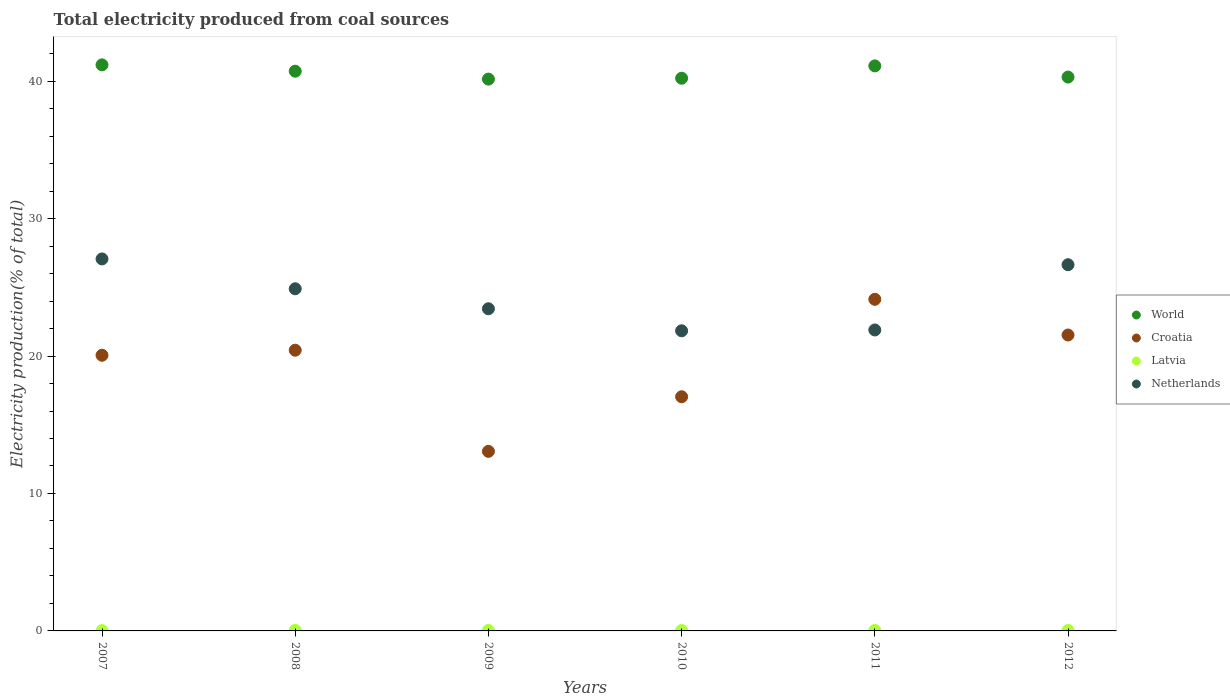How many different coloured dotlines are there?
Your answer should be compact. 4. Is the number of dotlines equal to the number of legend labels?
Make the answer very short. Yes. What is the total electricity produced in Latvia in 2010?
Your response must be concise. 0.03. Across all years, what is the maximum total electricity produced in Latvia?
Offer a very short reply. 0.04. Across all years, what is the minimum total electricity produced in World?
Make the answer very short. 40.15. What is the total total electricity produced in Croatia in the graph?
Give a very brief answer. 116.24. What is the difference between the total electricity produced in Netherlands in 2011 and that in 2012?
Your response must be concise. -4.75. What is the difference between the total electricity produced in Latvia in 2008 and the total electricity produced in World in 2007?
Offer a terse response. -41.15. What is the average total electricity produced in Netherlands per year?
Your answer should be compact. 24.3. In the year 2008, what is the difference between the total electricity produced in Netherlands and total electricity produced in World?
Your response must be concise. -15.83. What is the ratio of the total electricity produced in Netherlands in 2009 to that in 2010?
Keep it short and to the point. 1.07. What is the difference between the highest and the second highest total electricity produced in World?
Offer a terse response. 0.07. What is the difference between the highest and the lowest total electricity produced in Latvia?
Offer a very short reply. 0.02. In how many years, is the total electricity produced in Latvia greater than the average total electricity produced in Latvia taken over all years?
Keep it short and to the point. 4. Is the sum of the total electricity produced in Netherlands in 2010 and 2011 greater than the maximum total electricity produced in Latvia across all years?
Offer a very short reply. Yes. Is it the case that in every year, the sum of the total electricity produced in Latvia and total electricity produced in World  is greater than the total electricity produced in Netherlands?
Your answer should be compact. Yes. Is the total electricity produced in Netherlands strictly greater than the total electricity produced in Croatia over the years?
Provide a succinct answer. No. Is the total electricity produced in Netherlands strictly less than the total electricity produced in Latvia over the years?
Your answer should be compact. No. How many years are there in the graph?
Give a very brief answer. 6. What is the difference between two consecutive major ticks on the Y-axis?
Provide a succinct answer. 10. Does the graph contain grids?
Your answer should be very brief. No. Where does the legend appear in the graph?
Make the answer very short. Center right. How many legend labels are there?
Give a very brief answer. 4. How are the legend labels stacked?
Offer a very short reply. Vertical. What is the title of the graph?
Your answer should be very brief. Total electricity produced from coal sources. Does "Costa Rica" appear as one of the legend labels in the graph?
Keep it short and to the point. No. What is the label or title of the Y-axis?
Your answer should be compact. Electricity production(% of total). What is the Electricity production(% of total) of World in 2007?
Offer a very short reply. 41.18. What is the Electricity production(% of total) in Croatia in 2007?
Keep it short and to the point. 20.06. What is the Electricity production(% of total) of Latvia in 2007?
Your response must be concise. 0.02. What is the Electricity production(% of total) in Netherlands in 2007?
Provide a succinct answer. 27.06. What is the Electricity production(% of total) in World in 2008?
Your response must be concise. 40.72. What is the Electricity production(% of total) of Croatia in 2008?
Keep it short and to the point. 20.42. What is the Electricity production(% of total) of Latvia in 2008?
Give a very brief answer. 0.04. What is the Electricity production(% of total) of Netherlands in 2008?
Provide a short and direct response. 24.89. What is the Electricity production(% of total) of World in 2009?
Your answer should be compact. 40.15. What is the Electricity production(% of total) of Croatia in 2009?
Your answer should be very brief. 13.06. What is the Electricity production(% of total) in Latvia in 2009?
Ensure brevity in your answer.  0.04. What is the Electricity production(% of total) in Netherlands in 2009?
Your answer should be compact. 23.44. What is the Electricity production(% of total) of World in 2010?
Your answer should be compact. 40.21. What is the Electricity production(% of total) in Croatia in 2010?
Your response must be concise. 17.04. What is the Electricity production(% of total) of Latvia in 2010?
Your answer should be very brief. 0.03. What is the Electricity production(% of total) in Netherlands in 2010?
Keep it short and to the point. 21.84. What is the Electricity production(% of total) of World in 2011?
Give a very brief answer. 41.11. What is the Electricity production(% of total) of Croatia in 2011?
Offer a very short reply. 24.13. What is the Electricity production(% of total) in Latvia in 2011?
Your answer should be very brief. 0.03. What is the Electricity production(% of total) of Netherlands in 2011?
Make the answer very short. 21.9. What is the Electricity production(% of total) of World in 2012?
Offer a terse response. 40.3. What is the Electricity production(% of total) of Croatia in 2012?
Ensure brevity in your answer.  21.53. What is the Electricity production(% of total) of Latvia in 2012?
Your response must be concise. 0.03. What is the Electricity production(% of total) of Netherlands in 2012?
Give a very brief answer. 26.64. Across all years, what is the maximum Electricity production(% of total) of World?
Your answer should be compact. 41.18. Across all years, what is the maximum Electricity production(% of total) in Croatia?
Keep it short and to the point. 24.13. Across all years, what is the maximum Electricity production(% of total) of Latvia?
Offer a terse response. 0.04. Across all years, what is the maximum Electricity production(% of total) in Netherlands?
Provide a short and direct response. 27.06. Across all years, what is the minimum Electricity production(% of total) in World?
Your answer should be very brief. 40.15. Across all years, what is the minimum Electricity production(% of total) of Croatia?
Your answer should be compact. 13.06. Across all years, what is the minimum Electricity production(% of total) in Latvia?
Make the answer very short. 0.02. Across all years, what is the minimum Electricity production(% of total) in Netherlands?
Offer a very short reply. 21.84. What is the total Electricity production(% of total) of World in the graph?
Provide a short and direct response. 243.68. What is the total Electricity production(% of total) of Croatia in the graph?
Make the answer very short. 116.24. What is the total Electricity production(% of total) in Latvia in the graph?
Provide a short and direct response. 0.19. What is the total Electricity production(% of total) in Netherlands in the graph?
Your answer should be very brief. 145.78. What is the difference between the Electricity production(% of total) in World in 2007 and that in 2008?
Make the answer very short. 0.46. What is the difference between the Electricity production(% of total) in Croatia in 2007 and that in 2008?
Offer a terse response. -0.37. What is the difference between the Electricity production(% of total) of Latvia in 2007 and that in 2008?
Make the answer very short. -0.02. What is the difference between the Electricity production(% of total) of Netherlands in 2007 and that in 2008?
Your response must be concise. 2.17. What is the difference between the Electricity production(% of total) in World in 2007 and that in 2009?
Your answer should be very brief. 1.04. What is the difference between the Electricity production(% of total) in Croatia in 2007 and that in 2009?
Your response must be concise. 6.99. What is the difference between the Electricity production(% of total) in Latvia in 2007 and that in 2009?
Keep it short and to the point. -0.01. What is the difference between the Electricity production(% of total) of Netherlands in 2007 and that in 2009?
Provide a succinct answer. 3.62. What is the difference between the Electricity production(% of total) in World in 2007 and that in 2010?
Your answer should be very brief. 0.97. What is the difference between the Electricity production(% of total) of Croatia in 2007 and that in 2010?
Your answer should be compact. 3.02. What is the difference between the Electricity production(% of total) in Latvia in 2007 and that in 2010?
Your response must be concise. -0.01. What is the difference between the Electricity production(% of total) of Netherlands in 2007 and that in 2010?
Your answer should be compact. 5.23. What is the difference between the Electricity production(% of total) in World in 2007 and that in 2011?
Make the answer very short. 0.07. What is the difference between the Electricity production(% of total) of Croatia in 2007 and that in 2011?
Ensure brevity in your answer.  -4.07. What is the difference between the Electricity production(% of total) of Latvia in 2007 and that in 2011?
Provide a succinct answer. -0.01. What is the difference between the Electricity production(% of total) in Netherlands in 2007 and that in 2011?
Provide a short and direct response. 5.17. What is the difference between the Electricity production(% of total) of World in 2007 and that in 2012?
Offer a terse response. 0.89. What is the difference between the Electricity production(% of total) of Croatia in 2007 and that in 2012?
Keep it short and to the point. -1.47. What is the difference between the Electricity production(% of total) in Latvia in 2007 and that in 2012?
Offer a terse response. -0.01. What is the difference between the Electricity production(% of total) of Netherlands in 2007 and that in 2012?
Ensure brevity in your answer.  0.42. What is the difference between the Electricity production(% of total) of World in 2008 and that in 2009?
Your response must be concise. 0.58. What is the difference between the Electricity production(% of total) of Croatia in 2008 and that in 2009?
Make the answer very short. 7.36. What is the difference between the Electricity production(% of total) in Latvia in 2008 and that in 2009?
Offer a terse response. 0. What is the difference between the Electricity production(% of total) of Netherlands in 2008 and that in 2009?
Your response must be concise. 1.45. What is the difference between the Electricity production(% of total) in World in 2008 and that in 2010?
Ensure brevity in your answer.  0.51. What is the difference between the Electricity production(% of total) in Croatia in 2008 and that in 2010?
Keep it short and to the point. 3.39. What is the difference between the Electricity production(% of total) in Latvia in 2008 and that in 2010?
Provide a succinct answer. 0.01. What is the difference between the Electricity production(% of total) in Netherlands in 2008 and that in 2010?
Keep it short and to the point. 3.06. What is the difference between the Electricity production(% of total) in World in 2008 and that in 2011?
Provide a succinct answer. -0.39. What is the difference between the Electricity production(% of total) in Croatia in 2008 and that in 2011?
Your answer should be compact. -3.7. What is the difference between the Electricity production(% of total) of Latvia in 2008 and that in 2011?
Your answer should be very brief. 0.01. What is the difference between the Electricity production(% of total) in Netherlands in 2008 and that in 2011?
Give a very brief answer. 3. What is the difference between the Electricity production(% of total) in World in 2008 and that in 2012?
Your answer should be very brief. 0.43. What is the difference between the Electricity production(% of total) in Croatia in 2008 and that in 2012?
Offer a terse response. -1.11. What is the difference between the Electricity production(% of total) in Latvia in 2008 and that in 2012?
Ensure brevity in your answer.  0.01. What is the difference between the Electricity production(% of total) of Netherlands in 2008 and that in 2012?
Your answer should be compact. -1.75. What is the difference between the Electricity production(% of total) in World in 2009 and that in 2010?
Ensure brevity in your answer.  -0.06. What is the difference between the Electricity production(% of total) in Croatia in 2009 and that in 2010?
Ensure brevity in your answer.  -3.97. What is the difference between the Electricity production(% of total) in Latvia in 2009 and that in 2010?
Your answer should be compact. 0.01. What is the difference between the Electricity production(% of total) in Netherlands in 2009 and that in 2010?
Ensure brevity in your answer.  1.6. What is the difference between the Electricity production(% of total) of World in 2009 and that in 2011?
Offer a very short reply. -0.96. What is the difference between the Electricity production(% of total) in Croatia in 2009 and that in 2011?
Your answer should be very brief. -11.06. What is the difference between the Electricity production(% of total) in Latvia in 2009 and that in 2011?
Your answer should be very brief. 0. What is the difference between the Electricity production(% of total) of Netherlands in 2009 and that in 2011?
Your answer should be very brief. 1.54. What is the difference between the Electricity production(% of total) of World in 2009 and that in 2012?
Keep it short and to the point. -0.15. What is the difference between the Electricity production(% of total) of Croatia in 2009 and that in 2012?
Provide a short and direct response. -8.47. What is the difference between the Electricity production(% of total) in Latvia in 2009 and that in 2012?
Give a very brief answer. 0. What is the difference between the Electricity production(% of total) in Netherlands in 2009 and that in 2012?
Provide a short and direct response. -3.2. What is the difference between the Electricity production(% of total) in World in 2010 and that in 2011?
Your response must be concise. -0.9. What is the difference between the Electricity production(% of total) of Croatia in 2010 and that in 2011?
Your answer should be very brief. -7.09. What is the difference between the Electricity production(% of total) in Latvia in 2010 and that in 2011?
Ensure brevity in your answer.  -0. What is the difference between the Electricity production(% of total) of Netherlands in 2010 and that in 2011?
Your answer should be compact. -0.06. What is the difference between the Electricity production(% of total) in World in 2010 and that in 2012?
Keep it short and to the point. -0.09. What is the difference between the Electricity production(% of total) in Croatia in 2010 and that in 2012?
Keep it short and to the point. -4.49. What is the difference between the Electricity production(% of total) of Latvia in 2010 and that in 2012?
Provide a short and direct response. -0. What is the difference between the Electricity production(% of total) of Netherlands in 2010 and that in 2012?
Offer a terse response. -4.81. What is the difference between the Electricity production(% of total) of World in 2011 and that in 2012?
Provide a short and direct response. 0.81. What is the difference between the Electricity production(% of total) in Croatia in 2011 and that in 2012?
Your response must be concise. 2.6. What is the difference between the Electricity production(% of total) in Netherlands in 2011 and that in 2012?
Provide a short and direct response. -4.75. What is the difference between the Electricity production(% of total) in World in 2007 and the Electricity production(% of total) in Croatia in 2008?
Provide a succinct answer. 20.76. What is the difference between the Electricity production(% of total) of World in 2007 and the Electricity production(% of total) of Latvia in 2008?
Give a very brief answer. 41.15. What is the difference between the Electricity production(% of total) in World in 2007 and the Electricity production(% of total) in Netherlands in 2008?
Your answer should be compact. 16.29. What is the difference between the Electricity production(% of total) of Croatia in 2007 and the Electricity production(% of total) of Latvia in 2008?
Make the answer very short. 20.02. What is the difference between the Electricity production(% of total) in Croatia in 2007 and the Electricity production(% of total) in Netherlands in 2008?
Ensure brevity in your answer.  -4.84. What is the difference between the Electricity production(% of total) in Latvia in 2007 and the Electricity production(% of total) in Netherlands in 2008?
Give a very brief answer. -24.87. What is the difference between the Electricity production(% of total) in World in 2007 and the Electricity production(% of total) in Croatia in 2009?
Your answer should be very brief. 28.12. What is the difference between the Electricity production(% of total) of World in 2007 and the Electricity production(% of total) of Latvia in 2009?
Make the answer very short. 41.15. What is the difference between the Electricity production(% of total) in World in 2007 and the Electricity production(% of total) in Netherlands in 2009?
Provide a succinct answer. 17.74. What is the difference between the Electricity production(% of total) in Croatia in 2007 and the Electricity production(% of total) in Latvia in 2009?
Ensure brevity in your answer.  20.02. What is the difference between the Electricity production(% of total) of Croatia in 2007 and the Electricity production(% of total) of Netherlands in 2009?
Your response must be concise. -3.38. What is the difference between the Electricity production(% of total) in Latvia in 2007 and the Electricity production(% of total) in Netherlands in 2009?
Give a very brief answer. -23.42. What is the difference between the Electricity production(% of total) of World in 2007 and the Electricity production(% of total) of Croatia in 2010?
Offer a very short reply. 24.15. What is the difference between the Electricity production(% of total) of World in 2007 and the Electricity production(% of total) of Latvia in 2010?
Make the answer very short. 41.15. What is the difference between the Electricity production(% of total) of World in 2007 and the Electricity production(% of total) of Netherlands in 2010?
Your response must be concise. 19.35. What is the difference between the Electricity production(% of total) in Croatia in 2007 and the Electricity production(% of total) in Latvia in 2010?
Ensure brevity in your answer.  20.03. What is the difference between the Electricity production(% of total) of Croatia in 2007 and the Electricity production(% of total) of Netherlands in 2010?
Make the answer very short. -1.78. What is the difference between the Electricity production(% of total) of Latvia in 2007 and the Electricity production(% of total) of Netherlands in 2010?
Offer a terse response. -21.82. What is the difference between the Electricity production(% of total) in World in 2007 and the Electricity production(% of total) in Croatia in 2011?
Your answer should be compact. 17.06. What is the difference between the Electricity production(% of total) of World in 2007 and the Electricity production(% of total) of Latvia in 2011?
Your answer should be very brief. 41.15. What is the difference between the Electricity production(% of total) in World in 2007 and the Electricity production(% of total) in Netherlands in 2011?
Ensure brevity in your answer.  19.29. What is the difference between the Electricity production(% of total) of Croatia in 2007 and the Electricity production(% of total) of Latvia in 2011?
Offer a very short reply. 20.02. What is the difference between the Electricity production(% of total) of Croatia in 2007 and the Electricity production(% of total) of Netherlands in 2011?
Offer a very short reply. -1.84. What is the difference between the Electricity production(% of total) in Latvia in 2007 and the Electricity production(% of total) in Netherlands in 2011?
Provide a short and direct response. -21.88. What is the difference between the Electricity production(% of total) of World in 2007 and the Electricity production(% of total) of Croatia in 2012?
Give a very brief answer. 19.66. What is the difference between the Electricity production(% of total) of World in 2007 and the Electricity production(% of total) of Latvia in 2012?
Give a very brief answer. 41.15. What is the difference between the Electricity production(% of total) of World in 2007 and the Electricity production(% of total) of Netherlands in 2012?
Your response must be concise. 14.54. What is the difference between the Electricity production(% of total) of Croatia in 2007 and the Electricity production(% of total) of Latvia in 2012?
Your response must be concise. 20.02. What is the difference between the Electricity production(% of total) of Croatia in 2007 and the Electricity production(% of total) of Netherlands in 2012?
Keep it short and to the point. -6.59. What is the difference between the Electricity production(% of total) in Latvia in 2007 and the Electricity production(% of total) in Netherlands in 2012?
Keep it short and to the point. -26.62. What is the difference between the Electricity production(% of total) in World in 2008 and the Electricity production(% of total) in Croatia in 2009?
Your response must be concise. 27.66. What is the difference between the Electricity production(% of total) of World in 2008 and the Electricity production(% of total) of Latvia in 2009?
Provide a succinct answer. 40.69. What is the difference between the Electricity production(% of total) of World in 2008 and the Electricity production(% of total) of Netherlands in 2009?
Provide a succinct answer. 17.28. What is the difference between the Electricity production(% of total) of Croatia in 2008 and the Electricity production(% of total) of Latvia in 2009?
Offer a terse response. 20.39. What is the difference between the Electricity production(% of total) in Croatia in 2008 and the Electricity production(% of total) in Netherlands in 2009?
Your answer should be compact. -3.02. What is the difference between the Electricity production(% of total) of Latvia in 2008 and the Electricity production(% of total) of Netherlands in 2009?
Offer a terse response. -23.4. What is the difference between the Electricity production(% of total) in World in 2008 and the Electricity production(% of total) in Croatia in 2010?
Ensure brevity in your answer.  23.69. What is the difference between the Electricity production(% of total) of World in 2008 and the Electricity production(% of total) of Latvia in 2010?
Keep it short and to the point. 40.69. What is the difference between the Electricity production(% of total) in World in 2008 and the Electricity production(% of total) in Netherlands in 2010?
Make the answer very short. 18.89. What is the difference between the Electricity production(% of total) of Croatia in 2008 and the Electricity production(% of total) of Latvia in 2010?
Offer a very short reply. 20.39. What is the difference between the Electricity production(% of total) in Croatia in 2008 and the Electricity production(% of total) in Netherlands in 2010?
Give a very brief answer. -1.41. What is the difference between the Electricity production(% of total) of Latvia in 2008 and the Electricity production(% of total) of Netherlands in 2010?
Give a very brief answer. -21.8. What is the difference between the Electricity production(% of total) of World in 2008 and the Electricity production(% of total) of Croatia in 2011?
Offer a terse response. 16.6. What is the difference between the Electricity production(% of total) in World in 2008 and the Electricity production(% of total) in Latvia in 2011?
Your answer should be very brief. 40.69. What is the difference between the Electricity production(% of total) in World in 2008 and the Electricity production(% of total) in Netherlands in 2011?
Make the answer very short. 18.83. What is the difference between the Electricity production(% of total) of Croatia in 2008 and the Electricity production(% of total) of Latvia in 2011?
Your answer should be very brief. 20.39. What is the difference between the Electricity production(% of total) of Croatia in 2008 and the Electricity production(% of total) of Netherlands in 2011?
Provide a short and direct response. -1.47. What is the difference between the Electricity production(% of total) of Latvia in 2008 and the Electricity production(% of total) of Netherlands in 2011?
Offer a terse response. -21.86. What is the difference between the Electricity production(% of total) of World in 2008 and the Electricity production(% of total) of Croatia in 2012?
Make the answer very short. 19.19. What is the difference between the Electricity production(% of total) in World in 2008 and the Electricity production(% of total) in Latvia in 2012?
Provide a short and direct response. 40.69. What is the difference between the Electricity production(% of total) in World in 2008 and the Electricity production(% of total) in Netherlands in 2012?
Ensure brevity in your answer.  14.08. What is the difference between the Electricity production(% of total) in Croatia in 2008 and the Electricity production(% of total) in Latvia in 2012?
Your answer should be compact. 20.39. What is the difference between the Electricity production(% of total) of Croatia in 2008 and the Electricity production(% of total) of Netherlands in 2012?
Offer a very short reply. -6.22. What is the difference between the Electricity production(% of total) of Latvia in 2008 and the Electricity production(% of total) of Netherlands in 2012?
Your response must be concise. -26.61. What is the difference between the Electricity production(% of total) in World in 2009 and the Electricity production(% of total) in Croatia in 2010?
Provide a succinct answer. 23.11. What is the difference between the Electricity production(% of total) in World in 2009 and the Electricity production(% of total) in Latvia in 2010?
Provide a succinct answer. 40.12. What is the difference between the Electricity production(% of total) of World in 2009 and the Electricity production(% of total) of Netherlands in 2010?
Your answer should be very brief. 18.31. What is the difference between the Electricity production(% of total) in Croatia in 2009 and the Electricity production(% of total) in Latvia in 2010?
Provide a short and direct response. 13.03. What is the difference between the Electricity production(% of total) of Croatia in 2009 and the Electricity production(% of total) of Netherlands in 2010?
Give a very brief answer. -8.77. What is the difference between the Electricity production(% of total) in Latvia in 2009 and the Electricity production(% of total) in Netherlands in 2010?
Offer a very short reply. -21.8. What is the difference between the Electricity production(% of total) of World in 2009 and the Electricity production(% of total) of Croatia in 2011?
Your answer should be compact. 16.02. What is the difference between the Electricity production(% of total) in World in 2009 and the Electricity production(% of total) in Latvia in 2011?
Provide a succinct answer. 40.12. What is the difference between the Electricity production(% of total) in World in 2009 and the Electricity production(% of total) in Netherlands in 2011?
Your answer should be very brief. 18.25. What is the difference between the Electricity production(% of total) of Croatia in 2009 and the Electricity production(% of total) of Latvia in 2011?
Offer a terse response. 13.03. What is the difference between the Electricity production(% of total) in Croatia in 2009 and the Electricity production(% of total) in Netherlands in 2011?
Offer a very short reply. -8.83. What is the difference between the Electricity production(% of total) of Latvia in 2009 and the Electricity production(% of total) of Netherlands in 2011?
Ensure brevity in your answer.  -21.86. What is the difference between the Electricity production(% of total) in World in 2009 and the Electricity production(% of total) in Croatia in 2012?
Your answer should be very brief. 18.62. What is the difference between the Electricity production(% of total) of World in 2009 and the Electricity production(% of total) of Latvia in 2012?
Make the answer very short. 40.12. What is the difference between the Electricity production(% of total) in World in 2009 and the Electricity production(% of total) in Netherlands in 2012?
Provide a succinct answer. 13.5. What is the difference between the Electricity production(% of total) of Croatia in 2009 and the Electricity production(% of total) of Latvia in 2012?
Offer a terse response. 13.03. What is the difference between the Electricity production(% of total) of Croatia in 2009 and the Electricity production(% of total) of Netherlands in 2012?
Give a very brief answer. -13.58. What is the difference between the Electricity production(% of total) in Latvia in 2009 and the Electricity production(% of total) in Netherlands in 2012?
Your answer should be very brief. -26.61. What is the difference between the Electricity production(% of total) of World in 2010 and the Electricity production(% of total) of Croatia in 2011?
Ensure brevity in your answer.  16.09. What is the difference between the Electricity production(% of total) in World in 2010 and the Electricity production(% of total) in Latvia in 2011?
Your response must be concise. 40.18. What is the difference between the Electricity production(% of total) in World in 2010 and the Electricity production(% of total) in Netherlands in 2011?
Keep it short and to the point. 18.32. What is the difference between the Electricity production(% of total) of Croatia in 2010 and the Electricity production(% of total) of Latvia in 2011?
Your answer should be very brief. 17. What is the difference between the Electricity production(% of total) in Croatia in 2010 and the Electricity production(% of total) in Netherlands in 2011?
Your answer should be very brief. -4.86. What is the difference between the Electricity production(% of total) in Latvia in 2010 and the Electricity production(% of total) in Netherlands in 2011?
Your answer should be compact. -21.87. What is the difference between the Electricity production(% of total) of World in 2010 and the Electricity production(% of total) of Croatia in 2012?
Keep it short and to the point. 18.68. What is the difference between the Electricity production(% of total) in World in 2010 and the Electricity production(% of total) in Latvia in 2012?
Your answer should be very brief. 40.18. What is the difference between the Electricity production(% of total) of World in 2010 and the Electricity production(% of total) of Netherlands in 2012?
Your answer should be very brief. 13.57. What is the difference between the Electricity production(% of total) in Croatia in 2010 and the Electricity production(% of total) in Latvia in 2012?
Offer a very short reply. 17. What is the difference between the Electricity production(% of total) of Croatia in 2010 and the Electricity production(% of total) of Netherlands in 2012?
Your response must be concise. -9.61. What is the difference between the Electricity production(% of total) in Latvia in 2010 and the Electricity production(% of total) in Netherlands in 2012?
Provide a short and direct response. -26.61. What is the difference between the Electricity production(% of total) of World in 2011 and the Electricity production(% of total) of Croatia in 2012?
Ensure brevity in your answer.  19.58. What is the difference between the Electricity production(% of total) of World in 2011 and the Electricity production(% of total) of Latvia in 2012?
Your answer should be very brief. 41.08. What is the difference between the Electricity production(% of total) of World in 2011 and the Electricity production(% of total) of Netherlands in 2012?
Make the answer very short. 14.47. What is the difference between the Electricity production(% of total) of Croatia in 2011 and the Electricity production(% of total) of Latvia in 2012?
Make the answer very short. 24.09. What is the difference between the Electricity production(% of total) of Croatia in 2011 and the Electricity production(% of total) of Netherlands in 2012?
Ensure brevity in your answer.  -2.52. What is the difference between the Electricity production(% of total) in Latvia in 2011 and the Electricity production(% of total) in Netherlands in 2012?
Your answer should be compact. -26.61. What is the average Electricity production(% of total) of World per year?
Your response must be concise. 40.61. What is the average Electricity production(% of total) of Croatia per year?
Give a very brief answer. 19.37. What is the average Electricity production(% of total) of Latvia per year?
Your answer should be compact. 0.03. What is the average Electricity production(% of total) in Netherlands per year?
Keep it short and to the point. 24.3. In the year 2007, what is the difference between the Electricity production(% of total) in World and Electricity production(% of total) in Croatia?
Provide a succinct answer. 21.13. In the year 2007, what is the difference between the Electricity production(% of total) in World and Electricity production(% of total) in Latvia?
Give a very brief answer. 41.16. In the year 2007, what is the difference between the Electricity production(% of total) in World and Electricity production(% of total) in Netherlands?
Offer a terse response. 14.12. In the year 2007, what is the difference between the Electricity production(% of total) in Croatia and Electricity production(% of total) in Latvia?
Your response must be concise. 20.04. In the year 2007, what is the difference between the Electricity production(% of total) of Croatia and Electricity production(% of total) of Netherlands?
Provide a succinct answer. -7.01. In the year 2007, what is the difference between the Electricity production(% of total) of Latvia and Electricity production(% of total) of Netherlands?
Ensure brevity in your answer.  -27.04. In the year 2008, what is the difference between the Electricity production(% of total) of World and Electricity production(% of total) of Croatia?
Offer a very short reply. 20.3. In the year 2008, what is the difference between the Electricity production(% of total) in World and Electricity production(% of total) in Latvia?
Your response must be concise. 40.69. In the year 2008, what is the difference between the Electricity production(% of total) of World and Electricity production(% of total) of Netherlands?
Keep it short and to the point. 15.83. In the year 2008, what is the difference between the Electricity production(% of total) in Croatia and Electricity production(% of total) in Latvia?
Ensure brevity in your answer.  20.39. In the year 2008, what is the difference between the Electricity production(% of total) of Croatia and Electricity production(% of total) of Netherlands?
Provide a succinct answer. -4.47. In the year 2008, what is the difference between the Electricity production(% of total) in Latvia and Electricity production(% of total) in Netherlands?
Keep it short and to the point. -24.86. In the year 2009, what is the difference between the Electricity production(% of total) in World and Electricity production(% of total) in Croatia?
Keep it short and to the point. 27.08. In the year 2009, what is the difference between the Electricity production(% of total) in World and Electricity production(% of total) in Latvia?
Offer a terse response. 40.11. In the year 2009, what is the difference between the Electricity production(% of total) of World and Electricity production(% of total) of Netherlands?
Your answer should be compact. 16.71. In the year 2009, what is the difference between the Electricity production(% of total) of Croatia and Electricity production(% of total) of Latvia?
Provide a short and direct response. 13.03. In the year 2009, what is the difference between the Electricity production(% of total) in Croatia and Electricity production(% of total) in Netherlands?
Provide a succinct answer. -10.38. In the year 2009, what is the difference between the Electricity production(% of total) in Latvia and Electricity production(% of total) in Netherlands?
Keep it short and to the point. -23.4. In the year 2010, what is the difference between the Electricity production(% of total) in World and Electricity production(% of total) in Croatia?
Offer a very short reply. 23.18. In the year 2010, what is the difference between the Electricity production(% of total) of World and Electricity production(% of total) of Latvia?
Offer a terse response. 40.18. In the year 2010, what is the difference between the Electricity production(% of total) of World and Electricity production(% of total) of Netherlands?
Ensure brevity in your answer.  18.38. In the year 2010, what is the difference between the Electricity production(% of total) in Croatia and Electricity production(% of total) in Latvia?
Your response must be concise. 17.01. In the year 2010, what is the difference between the Electricity production(% of total) in Croatia and Electricity production(% of total) in Netherlands?
Your answer should be compact. -4.8. In the year 2010, what is the difference between the Electricity production(% of total) in Latvia and Electricity production(% of total) in Netherlands?
Keep it short and to the point. -21.81. In the year 2011, what is the difference between the Electricity production(% of total) of World and Electricity production(% of total) of Croatia?
Offer a very short reply. 16.98. In the year 2011, what is the difference between the Electricity production(% of total) of World and Electricity production(% of total) of Latvia?
Give a very brief answer. 41.08. In the year 2011, what is the difference between the Electricity production(% of total) in World and Electricity production(% of total) in Netherlands?
Offer a very short reply. 19.21. In the year 2011, what is the difference between the Electricity production(% of total) in Croatia and Electricity production(% of total) in Latvia?
Give a very brief answer. 24.09. In the year 2011, what is the difference between the Electricity production(% of total) in Croatia and Electricity production(% of total) in Netherlands?
Your answer should be compact. 2.23. In the year 2011, what is the difference between the Electricity production(% of total) in Latvia and Electricity production(% of total) in Netherlands?
Give a very brief answer. -21.86. In the year 2012, what is the difference between the Electricity production(% of total) in World and Electricity production(% of total) in Croatia?
Give a very brief answer. 18.77. In the year 2012, what is the difference between the Electricity production(% of total) of World and Electricity production(% of total) of Latvia?
Give a very brief answer. 40.27. In the year 2012, what is the difference between the Electricity production(% of total) of World and Electricity production(% of total) of Netherlands?
Ensure brevity in your answer.  13.65. In the year 2012, what is the difference between the Electricity production(% of total) in Croatia and Electricity production(% of total) in Latvia?
Your answer should be very brief. 21.5. In the year 2012, what is the difference between the Electricity production(% of total) in Croatia and Electricity production(% of total) in Netherlands?
Offer a very short reply. -5.11. In the year 2012, what is the difference between the Electricity production(% of total) in Latvia and Electricity production(% of total) in Netherlands?
Keep it short and to the point. -26.61. What is the ratio of the Electricity production(% of total) of World in 2007 to that in 2008?
Offer a terse response. 1.01. What is the ratio of the Electricity production(% of total) of Latvia in 2007 to that in 2008?
Offer a terse response. 0.55. What is the ratio of the Electricity production(% of total) in Netherlands in 2007 to that in 2008?
Your answer should be compact. 1.09. What is the ratio of the Electricity production(% of total) of World in 2007 to that in 2009?
Your response must be concise. 1.03. What is the ratio of the Electricity production(% of total) in Croatia in 2007 to that in 2009?
Offer a very short reply. 1.54. What is the ratio of the Electricity production(% of total) in Latvia in 2007 to that in 2009?
Keep it short and to the point. 0.58. What is the ratio of the Electricity production(% of total) of Netherlands in 2007 to that in 2009?
Make the answer very short. 1.15. What is the ratio of the Electricity production(% of total) in World in 2007 to that in 2010?
Provide a succinct answer. 1.02. What is the ratio of the Electricity production(% of total) of Croatia in 2007 to that in 2010?
Your answer should be compact. 1.18. What is the ratio of the Electricity production(% of total) of Latvia in 2007 to that in 2010?
Give a very brief answer. 0.69. What is the ratio of the Electricity production(% of total) in Netherlands in 2007 to that in 2010?
Offer a very short reply. 1.24. What is the ratio of the Electricity production(% of total) of World in 2007 to that in 2011?
Provide a succinct answer. 1. What is the ratio of the Electricity production(% of total) in Croatia in 2007 to that in 2011?
Give a very brief answer. 0.83. What is the ratio of the Electricity production(% of total) in Latvia in 2007 to that in 2011?
Make the answer very short. 0.64. What is the ratio of the Electricity production(% of total) of Netherlands in 2007 to that in 2011?
Offer a very short reply. 1.24. What is the ratio of the Electricity production(% of total) of World in 2007 to that in 2012?
Your answer should be compact. 1.02. What is the ratio of the Electricity production(% of total) in Croatia in 2007 to that in 2012?
Your response must be concise. 0.93. What is the ratio of the Electricity production(% of total) in Latvia in 2007 to that in 2012?
Keep it short and to the point. 0.65. What is the ratio of the Electricity production(% of total) in Netherlands in 2007 to that in 2012?
Ensure brevity in your answer.  1.02. What is the ratio of the Electricity production(% of total) in World in 2008 to that in 2009?
Make the answer very short. 1.01. What is the ratio of the Electricity production(% of total) in Croatia in 2008 to that in 2009?
Keep it short and to the point. 1.56. What is the ratio of the Electricity production(% of total) of Latvia in 2008 to that in 2009?
Make the answer very short. 1.06. What is the ratio of the Electricity production(% of total) in Netherlands in 2008 to that in 2009?
Your answer should be very brief. 1.06. What is the ratio of the Electricity production(% of total) of World in 2008 to that in 2010?
Your response must be concise. 1.01. What is the ratio of the Electricity production(% of total) of Croatia in 2008 to that in 2010?
Offer a very short reply. 1.2. What is the ratio of the Electricity production(% of total) in Latvia in 2008 to that in 2010?
Offer a very short reply. 1.26. What is the ratio of the Electricity production(% of total) of Netherlands in 2008 to that in 2010?
Your answer should be compact. 1.14. What is the ratio of the Electricity production(% of total) of World in 2008 to that in 2011?
Your answer should be very brief. 0.99. What is the ratio of the Electricity production(% of total) of Croatia in 2008 to that in 2011?
Offer a very short reply. 0.85. What is the ratio of the Electricity production(% of total) in Latvia in 2008 to that in 2011?
Give a very brief answer. 1.16. What is the ratio of the Electricity production(% of total) of Netherlands in 2008 to that in 2011?
Make the answer very short. 1.14. What is the ratio of the Electricity production(% of total) of World in 2008 to that in 2012?
Offer a very short reply. 1.01. What is the ratio of the Electricity production(% of total) of Croatia in 2008 to that in 2012?
Keep it short and to the point. 0.95. What is the ratio of the Electricity production(% of total) in Latvia in 2008 to that in 2012?
Your answer should be compact. 1.17. What is the ratio of the Electricity production(% of total) of Netherlands in 2008 to that in 2012?
Give a very brief answer. 0.93. What is the ratio of the Electricity production(% of total) in Croatia in 2009 to that in 2010?
Give a very brief answer. 0.77. What is the ratio of the Electricity production(% of total) in Latvia in 2009 to that in 2010?
Give a very brief answer. 1.19. What is the ratio of the Electricity production(% of total) in Netherlands in 2009 to that in 2010?
Provide a short and direct response. 1.07. What is the ratio of the Electricity production(% of total) of World in 2009 to that in 2011?
Make the answer very short. 0.98. What is the ratio of the Electricity production(% of total) in Croatia in 2009 to that in 2011?
Your response must be concise. 0.54. What is the ratio of the Electricity production(% of total) of Latvia in 2009 to that in 2011?
Your response must be concise. 1.09. What is the ratio of the Electricity production(% of total) in Netherlands in 2009 to that in 2011?
Give a very brief answer. 1.07. What is the ratio of the Electricity production(% of total) of Croatia in 2009 to that in 2012?
Make the answer very short. 0.61. What is the ratio of the Electricity production(% of total) in Latvia in 2009 to that in 2012?
Offer a terse response. 1.11. What is the ratio of the Electricity production(% of total) in Netherlands in 2009 to that in 2012?
Offer a very short reply. 0.88. What is the ratio of the Electricity production(% of total) in World in 2010 to that in 2011?
Your answer should be compact. 0.98. What is the ratio of the Electricity production(% of total) in Croatia in 2010 to that in 2011?
Provide a short and direct response. 0.71. What is the ratio of the Electricity production(% of total) of Latvia in 2010 to that in 2011?
Offer a terse response. 0.92. What is the ratio of the Electricity production(% of total) in Croatia in 2010 to that in 2012?
Offer a very short reply. 0.79. What is the ratio of the Electricity production(% of total) in Latvia in 2010 to that in 2012?
Provide a short and direct response. 0.93. What is the ratio of the Electricity production(% of total) in Netherlands in 2010 to that in 2012?
Keep it short and to the point. 0.82. What is the ratio of the Electricity production(% of total) of World in 2011 to that in 2012?
Make the answer very short. 1.02. What is the ratio of the Electricity production(% of total) of Croatia in 2011 to that in 2012?
Ensure brevity in your answer.  1.12. What is the ratio of the Electricity production(% of total) of Netherlands in 2011 to that in 2012?
Make the answer very short. 0.82. What is the difference between the highest and the second highest Electricity production(% of total) of World?
Offer a terse response. 0.07. What is the difference between the highest and the second highest Electricity production(% of total) of Croatia?
Provide a short and direct response. 2.6. What is the difference between the highest and the second highest Electricity production(% of total) of Latvia?
Make the answer very short. 0. What is the difference between the highest and the second highest Electricity production(% of total) in Netherlands?
Your response must be concise. 0.42. What is the difference between the highest and the lowest Electricity production(% of total) in World?
Provide a short and direct response. 1.04. What is the difference between the highest and the lowest Electricity production(% of total) in Croatia?
Offer a terse response. 11.06. What is the difference between the highest and the lowest Electricity production(% of total) of Latvia?
Offer a terse response. 0.02. What is the difference between the highest and the lowest Electricity production(% of total) of Netherlands?
Make the answer very short. 5.23. 